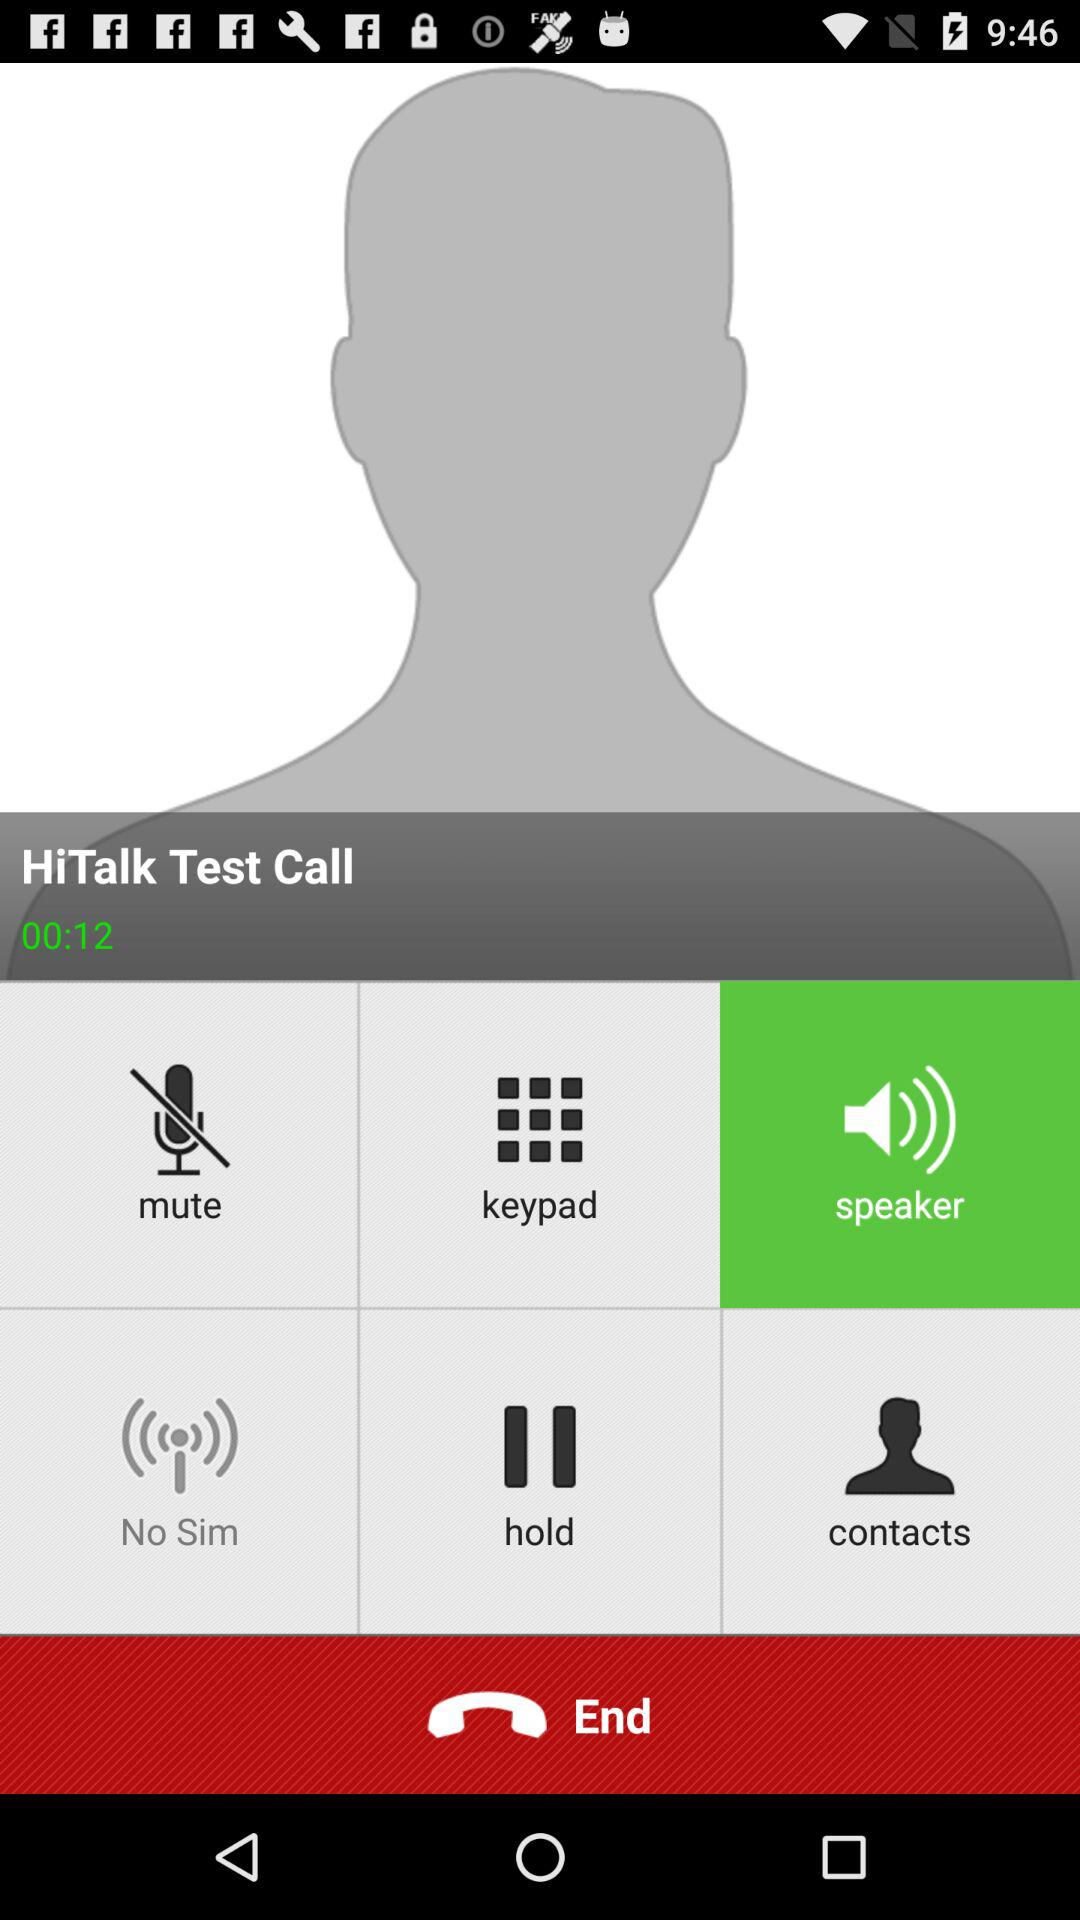What is the selected option? The selected option is "Speaker". 